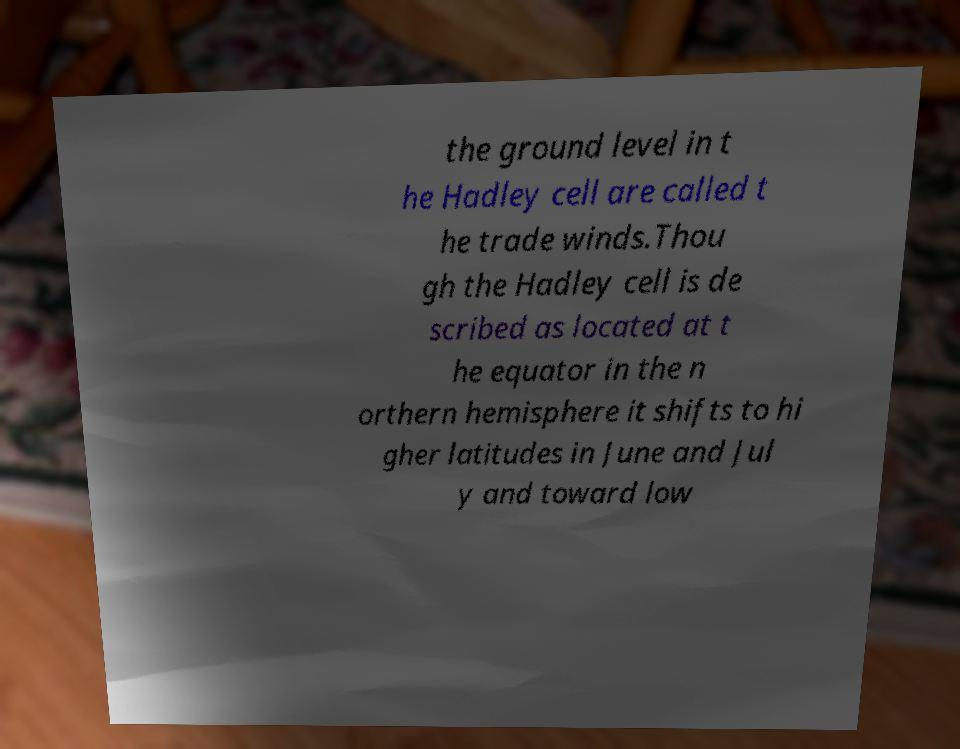Can you read and provide the text displayed in the image?This photo seems to have some interesting text. Can you extract and type it out for me? the ground level in t he Hadley cell are called t he trade winds.Thou gh the Hadley cell is de scribed as located at t he equator in the n orthern hemisphere it shifts to hi gher latitudes in June and Jul y and toward low 